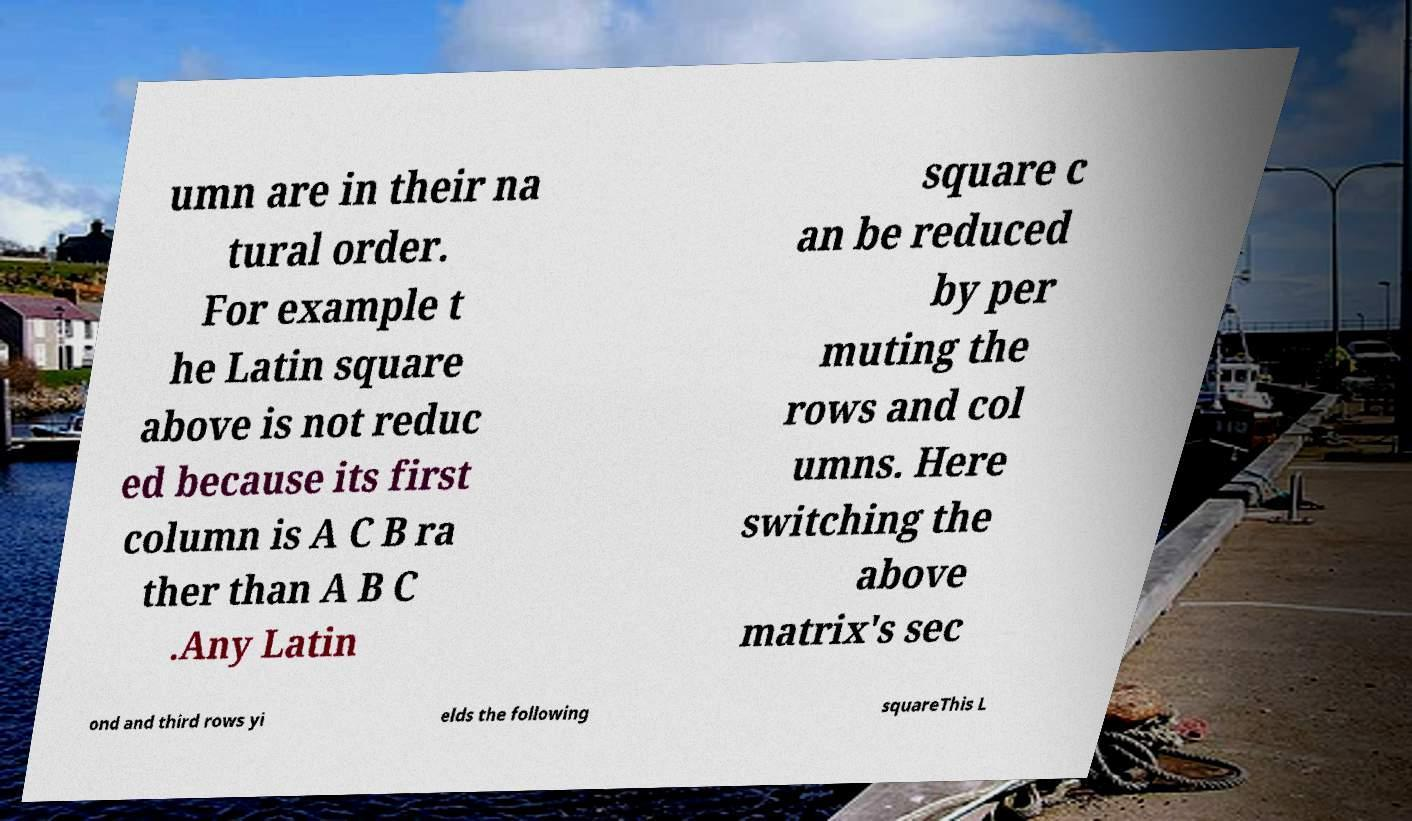I need the written content from this picture converted into text. Can you do that? umn are in their na tural order. For example t he Latin square above is not reduc ed because its first column is A C B ra ther than A B C .Any Latin square c an be reduced by per muting the rows and col umns. Here switching the above matrix's sec ond and third rows yi elds the following squareThis L 